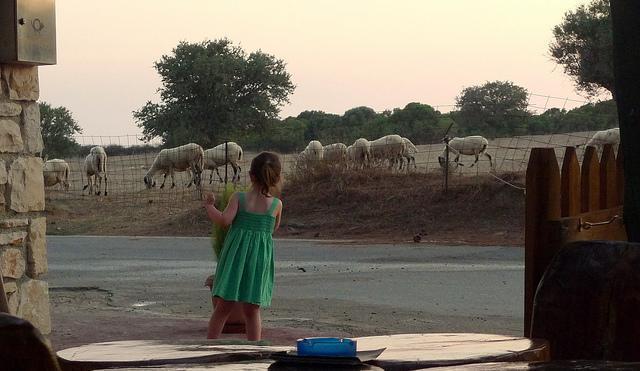What does the girl want to pet?
Choose the right answer and clarify with the format: 'Answer: answer
Rationale: rationale.'
Options: Foxes, snakes, sheep, chickens. Answer: sheep.
Rationale: A girl is looking at sheep in a pasture. 